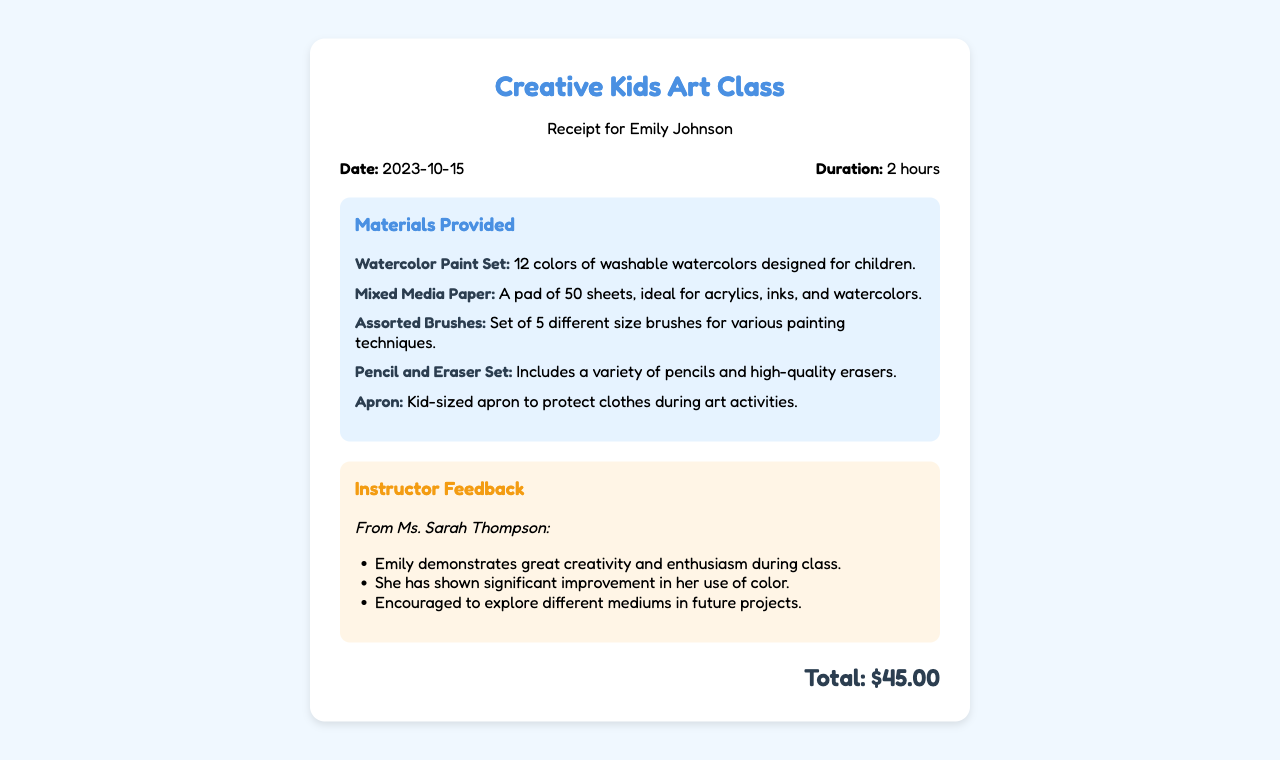What is the name of the child? The child's name is referenced in the receipt header as the recipient of the receipt.
Answer: Emily Johnson What is the date of the class? The date is listed prominently in the receipt under the information section.
Answer: 2023-10-15 How long did the class last? The duration is specified in the information section of the receipt.
Answer: 2 hours Who is the instructor? The instructor's name is found in the feedback section of the receipt.
Answer: Ms. Sarah Thompson What is the total cost for the class? The total amount paid is detailed at the bottom of the receipt.
Answer: $45.00 What type of paint set was provided? The materials section lists the specific type of paint set made available to students.
Answer: Watercolor Paint Set What did the instructor say about Emily's creativity? The feedback contains a specific comment about Emily's performance in class regarding creativity.
Answer: Great creativity and enthusiasm How many sheets are in the Mixed Media Paper pad? The number of sheets is mentioned in the description of the Mixed Media Paper provided.
Answer: 50 sheets What does the instructor encourage Emily to explore? A specific suggestion from the instructor is included in the feedback regarding Emily's future projects.
Answer: Different mediums 